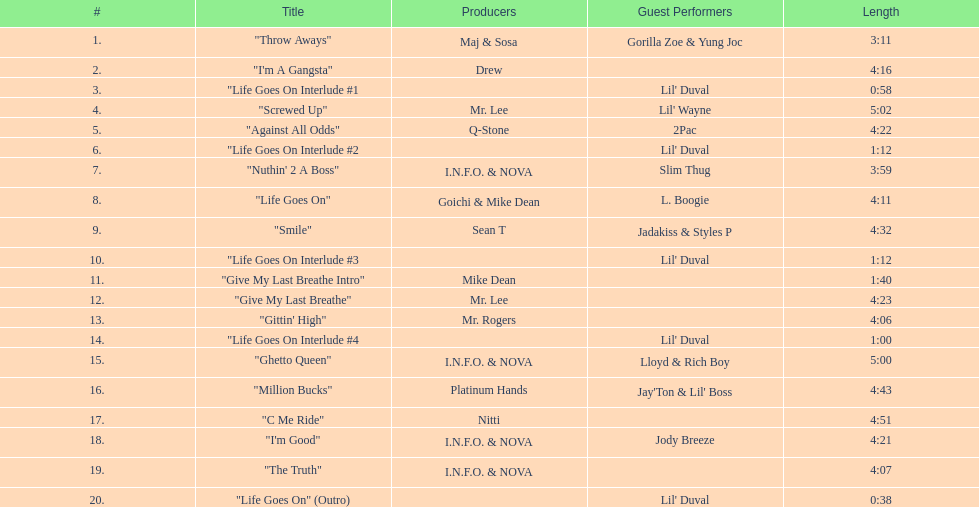How many tracks are there in total on the album? 20. 